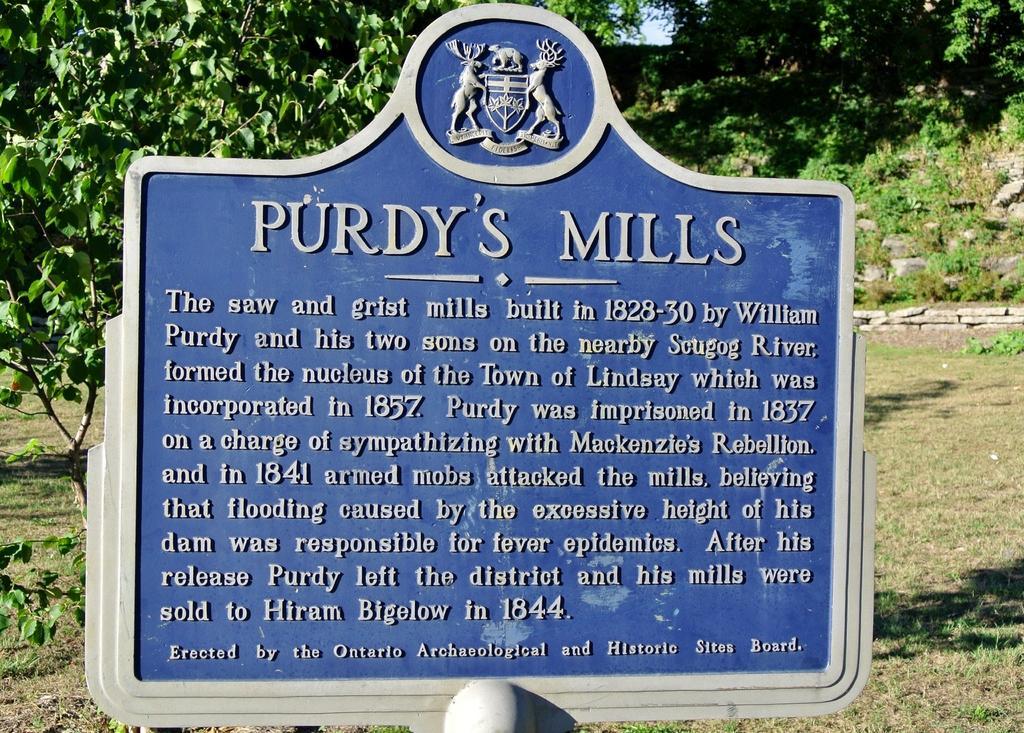Describe this image in one or two sentences. In this picture we can see the boards. At the top of the board we can see the statues and logo. In the background we can see the trees and farmland. On the right we can see some stones. 